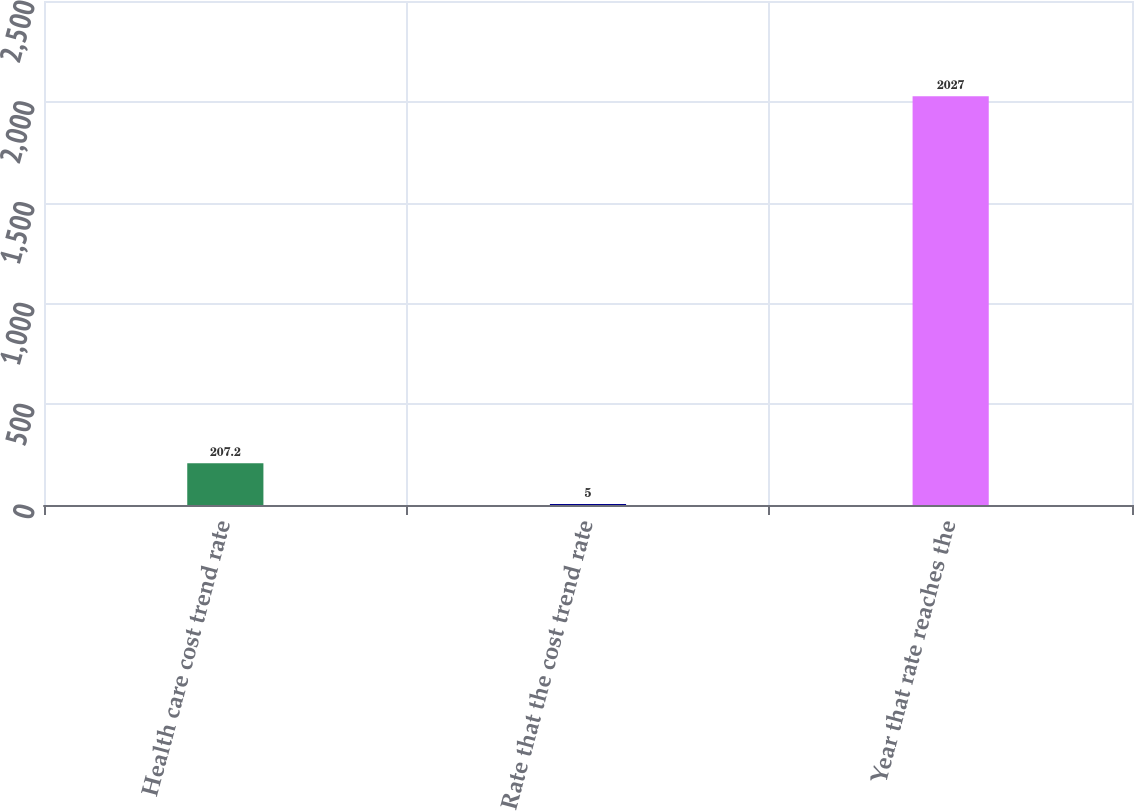Convert chart to OTSL. <chart><loc_0><loc_0><loc_500><loc_500><bar_chart><fcel>Health care cost trend rate<fcel>Rate that the cost trend rate<fcel>Year that rate reaches the<nl><fcel>207.2<fcel>5<fcel>2027<nl></chart> 